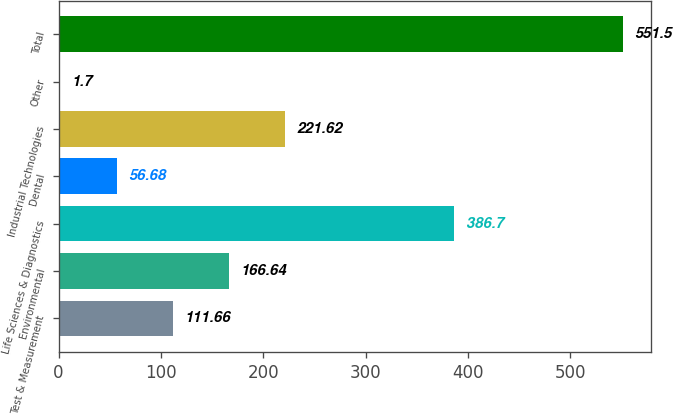Convert chart. <chart><loc_0><loc_0><loc_500><loc_500><bar_chart><fcel>Test & Measurement<fcel>Environmental<fcel>Life Sciences & Diagnostics<fcel>Dental<fcel>Industrial Technologies<fcel>Other<fcel>Total<nl><fcel>111.66<fcel>166.64<fcel>386.7<fcel>56.68<fcel>221.62<fcel>1.7<fcel>551.5<nl></chart> 